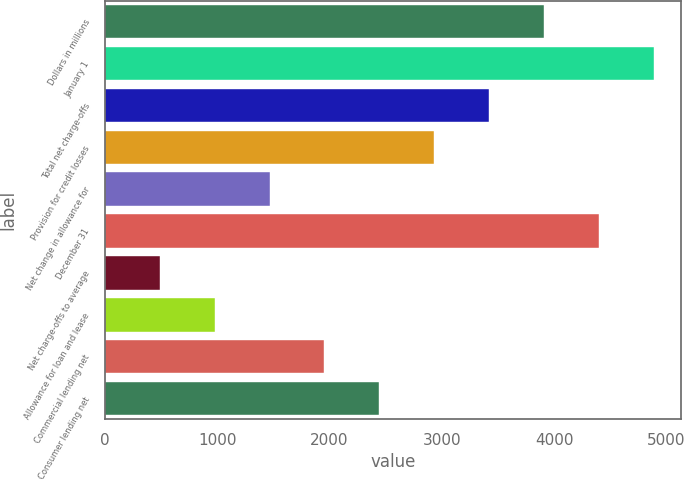Convert chart to OTSL. <chart><loc_0><loc_0><loc_500><loc_500><bar_chart><fcel>Dollars in millions<fcel>January 1<fcel>Total net charge-offs<fcel>Provision for credit losses<fcel>Net change in allowance for<fcel>December 31<fcel>Net charge-offs to average<fcel>Allowance for loan and lease<fcel>Commercial lending net<fcel>Consumer lending net<nl><fcel>3909.74<fcel>4887<fcel>3421.13<fcel>2932.52<fcel>1466.69<fcel>4398.35<fcel>489.47<fcel>978.08<fcel>1955.3<fcel>2443.91<nl></chart> 